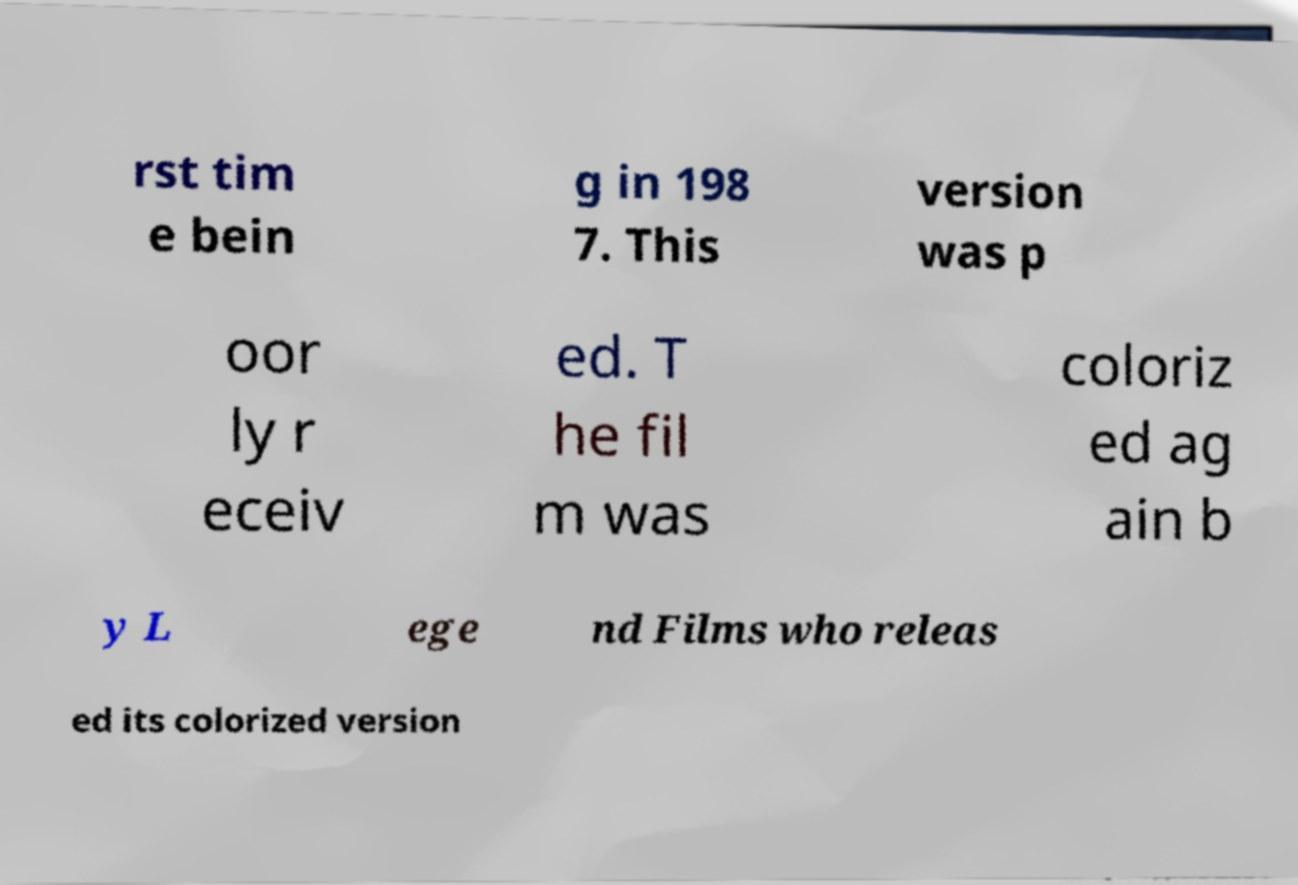Can you accurately transcribe the text from the provided image for me? rst tim e bein g in 198 7. This version was p oor ly r eceiv ed. T he fil m was coloriz ed ag ain b y L ege nd Films who releas ed its colorized version 